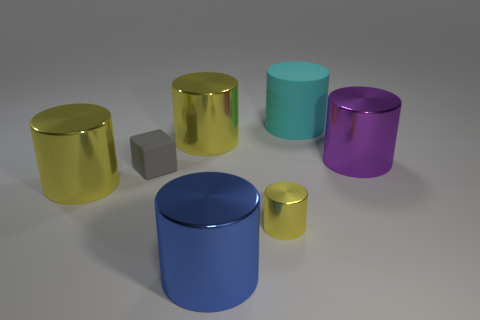Subtract all yellow cylinders. How many were subtracted if there are1yellow cylinders left? 2 Subtract all brown spheres. How many yellow cylinders are left? 3 Subtract all cyan cylinders. How many cylinders are left? 5 Subtract all cyan cylinders. How many cylinders are left? 5 Subtract all brown cylinders. Subtract all brown spheres. How many cylinders are left? 6 Add 3 big cyan things. How many objects exist? 10 Subtract all cylinders. How many objects are left? 1 Subtract 0 red cubes. How many objects are left? 7 Subtract all small matte blocks. Subtract all metal objects. How many objects are left? 1 Add 5 metallic cylinders. How many metallic cylinders are left? 10 